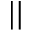<formula> <loc_0><loc_0><loc_500><loc_500>| |</formula> 